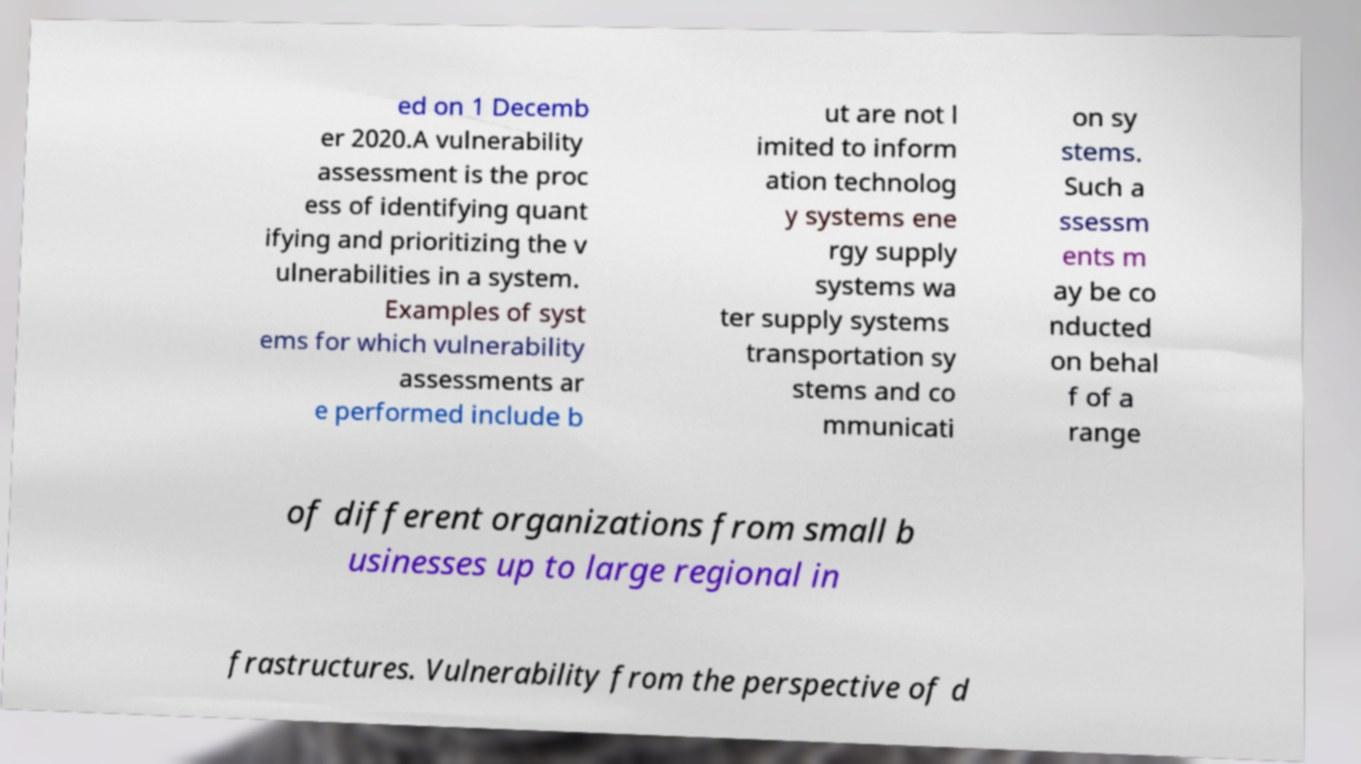I need the written content from this picture converted into text. Can you do that? ed on 1 Decemb er 2020.A vulnerability assessment is the proc ess of identifying quant ifying and prioritizing the v ulnerabilities in a system. Examples of syst ems for which vulnerability assessments ar e performed include b ut are not l imited to inform ation technolog y systems ene rgy supply systems wa ter supply systems transportation sy stems and co mmunicati on sy stems. Such a ssessm ents m ay be co nducted on behal f of a range of different organizations from small b usinesses up to large regional in frastructures. Vulnerability from the perspective of d 